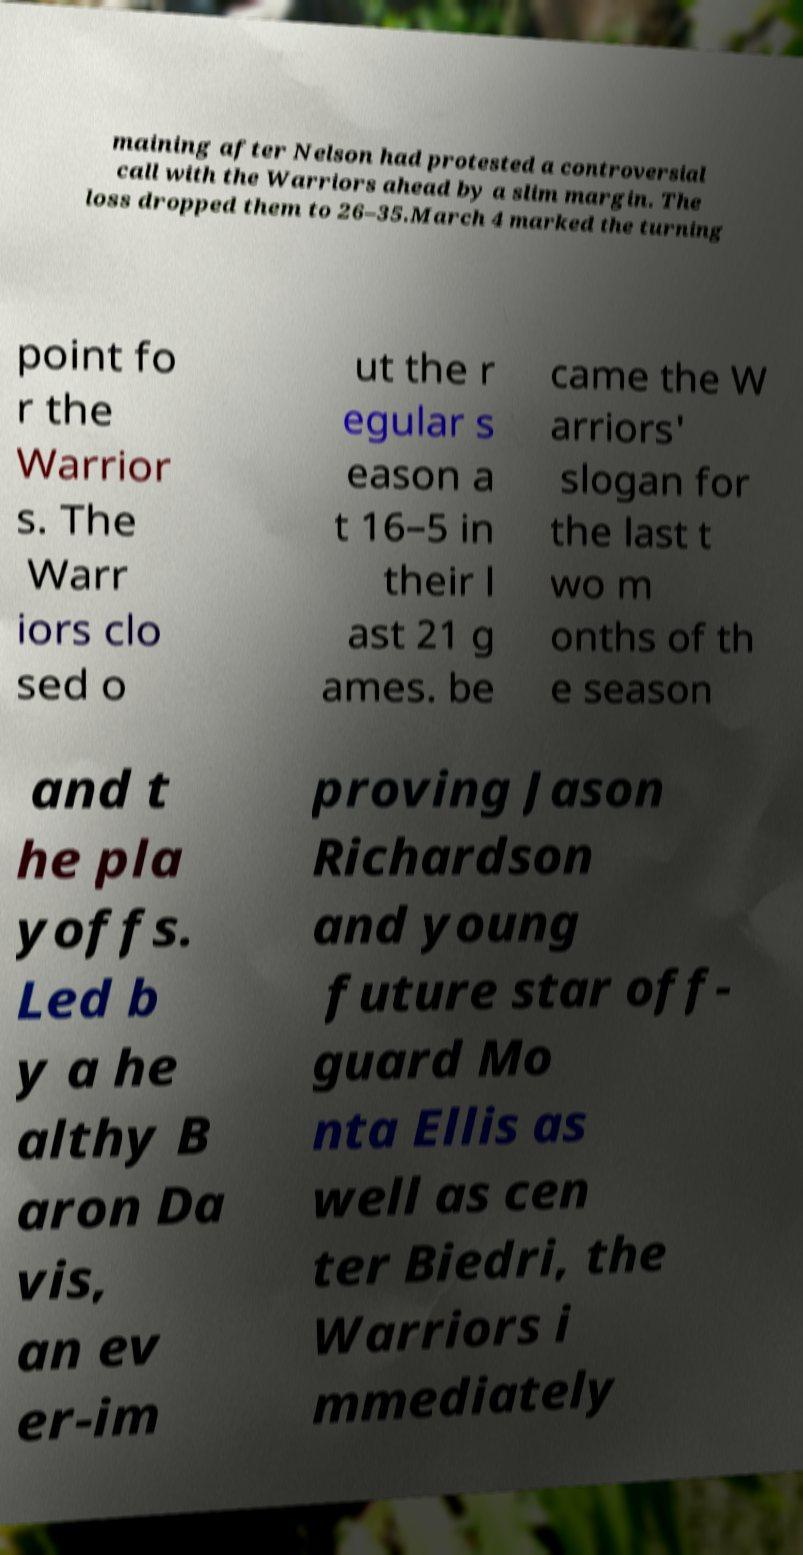Could you assist in decoding the text presented in this image and type it out clearly? maining after Nelson had protested a controversial call with the Warriors ahead by a slim margin. The loss dropped them to 26–35.March 4 marked the turning point fo r the Warrior s. The Warr iors clo sed o ut the r egular s eason a t 16–5 in their l ast 21 g ames. be came the W arriors' slogan for the last t wo m onths of th e season and t he pla yoffs. Led b y a he althy B aron Da vis, an ev er-im proving Jason Richardson and young future star off- guard Mo nta Ellis as well as cen ter Biedri, the Warriors i mmediately 